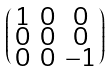Convert formula to latex. <formula><loc_0><loc_0><loc_500><loc_500>\begin{psmallmatrix} 1 & 0 & 0 \\ 0 & 0 & 0 \\ 0 & 0 & - 1 \end{psmallmatrix}</formula> 